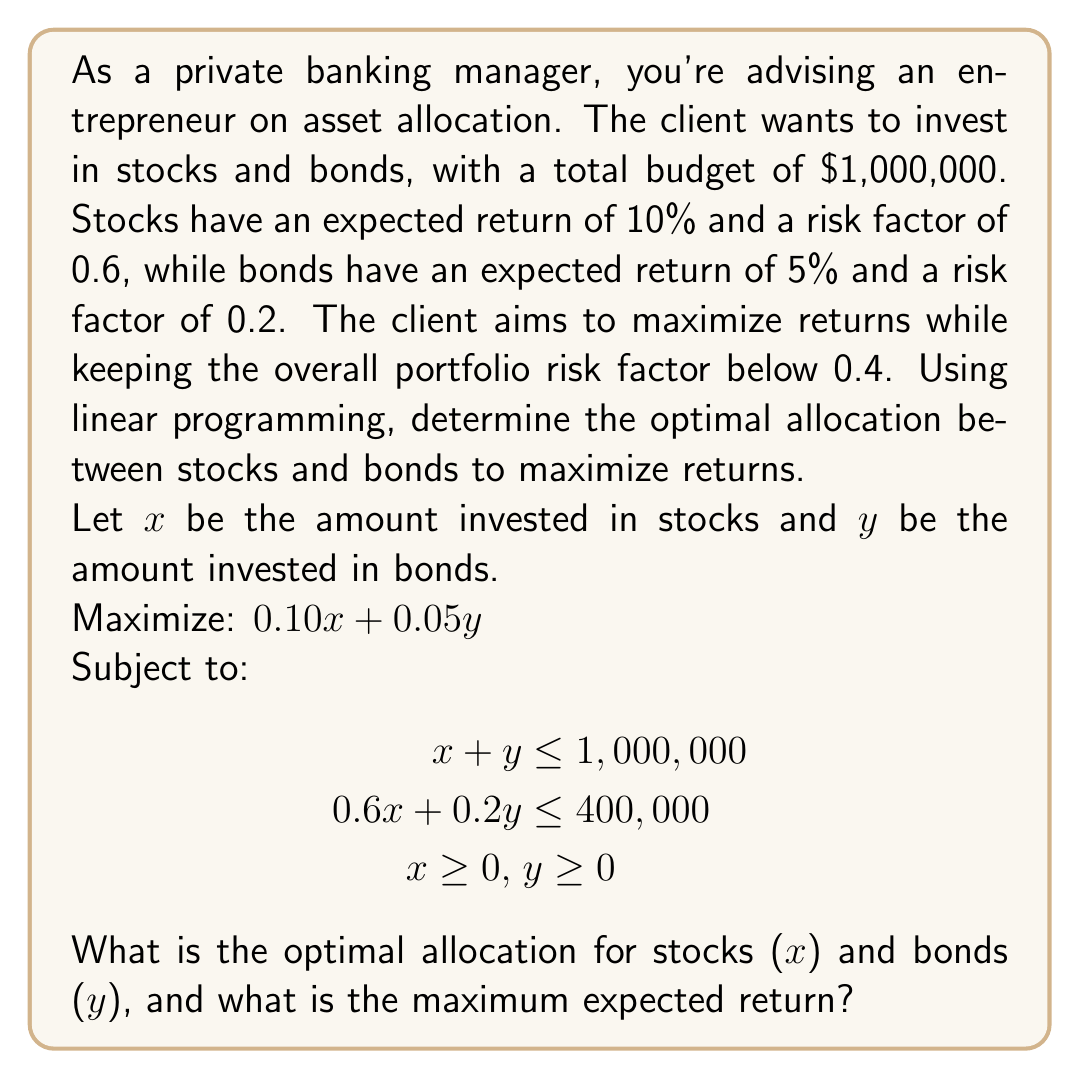Provide a solution to this math problem. To solve this linear programming problem, we'll use the graphical method:

1. Plot the constraints:
   a) Budget constraint: $x + y = 1,000,000$
   b) Risk constraint: $0.6x + 0.2y = 400,000$
   c) Non-negativity constraints: $x \geq 0, y \geq 0$

2. Identify the feasible region (the area that satisfies all constraints).

3. Find the corner points of the feasible region:
   - (0, 1,000,000): Budget constraint intersects y-axis
   - (666,667, 333,333): Intersection of budget and risk constraints
     Solving $x + y = 1,000,000$ and $0.6x + 0.2y = 400,000$:
     $0.6x + 0.2(1,000,000 - x) = 400,000$
     $0.6x + 200,000 - 0.2x = 400,000$
     $0.4x = 200,000$
     $x = 500,000$
     $y = 1,000,000 - 500,000 = 500,000$
   - (1,000,000, 0): Budget constraint intersects x-axis

4. Evaluate the objective function at each corner point:
   - (0, 1,000,000): $0.10(0) + 0.05(1,000,000) = 50,000$
   - (666,667, 333,333): $0.10(666,667) + 0.05(333,333) = 83,333$
   - (1,000,000, 0): $0.10(1,000,000) + 0.05(0) = 100,000$

5. The maximum value occurs at (666,667, 333,333), which satisfies all constraints.

Therefore, the optimal allocation is $666,667 for stocks and $333,333 for bonds, with a maximum expected return of $83,333.
Answer: Stocks: $666,667, Bonds: $333,333, Maximum return: $83,333 